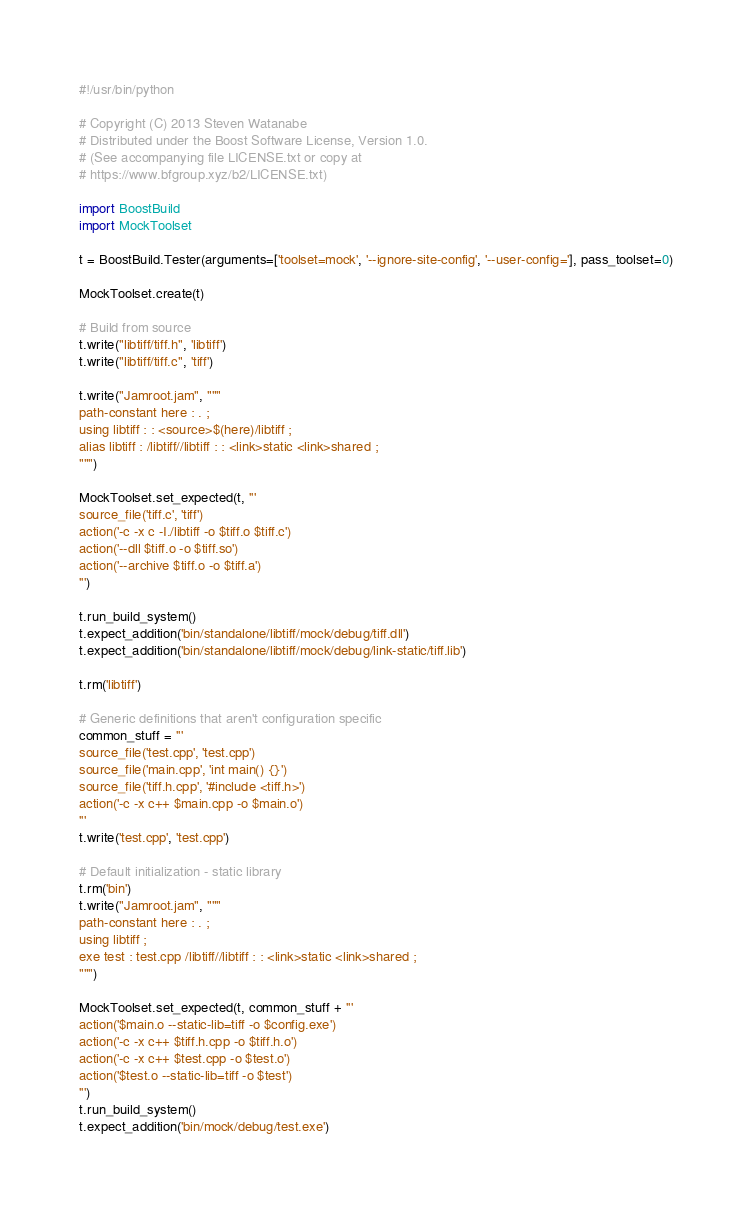<code> <loc_0><loc_0><loc_500><loc_500><_Python_>#!/usr/bin/python

# Copyright (C) 2013 Steven Watanabe
# Distributed under the Boost Software License, Version 1.0.
# (See accompanying file LICENSE.txt or copy at
# https://www.bfgroup.xyz/b2/LICENSE.txt)

import BoostBuild
import MockToolset

t = BoostBuild.Tester(arguments=['toolset=mock', '--ignore-site-config', '--user-config='], pass_toolset=0)

MockToolset.create(t)

# Build from source
t.write("libtiff/tiff.h", 'libtiff')
t.write("libtiff/tiff.c", 'tiff')

t.write("Jamroot.jam", """
path-constant here : . ;
using libtiff : : <source>$(here)/libtiff ;
alias libtiff : /libtiff//libtiff : : <link>static <link>shared ;
""")

MockToolset.set_expected(t, '''
source_file('tiff.c', 'tiff')
action('-c -x c -I./libtiff -o $tiff.o $tiff.c')
action('--dll $tiff.o -o $tiff.so')
action('--archive $tiff.o -o $tiff.a')
''')

t.run_build_system()
t.expect_addition('bin/standalone/libtiff/mock/debug/tiff.dll')
t.expect_addition('bin/standalone/libtiff/mock/debug/link-static/tiff.lib')

t.rm('libtiff')

# Generic definitions that aren't configuration specific
common_stuff = '''
source_file('test.cpp', 'test.cpp')
source_file('main.cpp', 'int main() {}')
source_file('tiff.h.cpp', '#include <tiff.h>')
action('-c -x c++ $main.cpp -o $main.o')
'''
t.write('test.cpp', 'test.cpp')

# Default initialization - static library
t.rm('bin')
t.write("Jamroot.jam", """
path-constant here : . ;
using libtiff ;
exe test : test.cpp /libtiff//libtiff : : <link>static <link>shared ;
""")

MockToolset.set_expected(t, common_stuff + '''
action('$main.o --static-lib=tiff -o $config.exe')
action('-c -x c++ $tiff.h.cpp -o $tiff.h.o')
action('-c -x c++ $test.cpp -o $test.o')
action('$test.o --static-lib=tiff -o $test')
''')
t.run_build_system()
t.expect_addition('bin/mock/debug/test.exe')</code> 